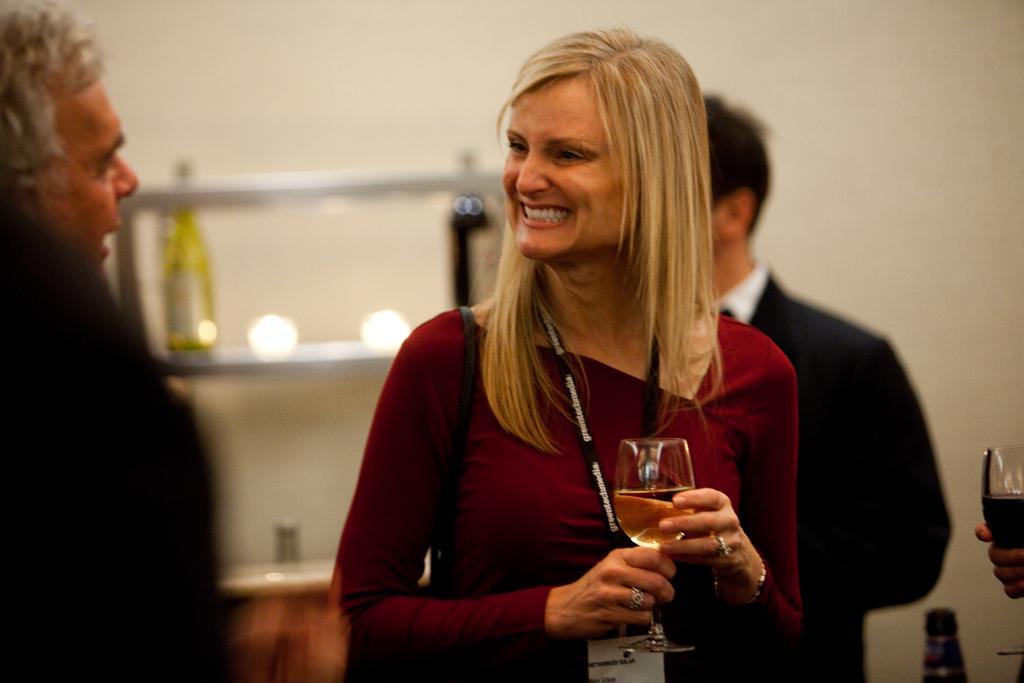Can you describe this image briefly? In this picture there is a lady at the center of the image by holding a juice glass in her hands she is laughing by seeing towards the left side and there is a man who is standing at the left side of the image. 